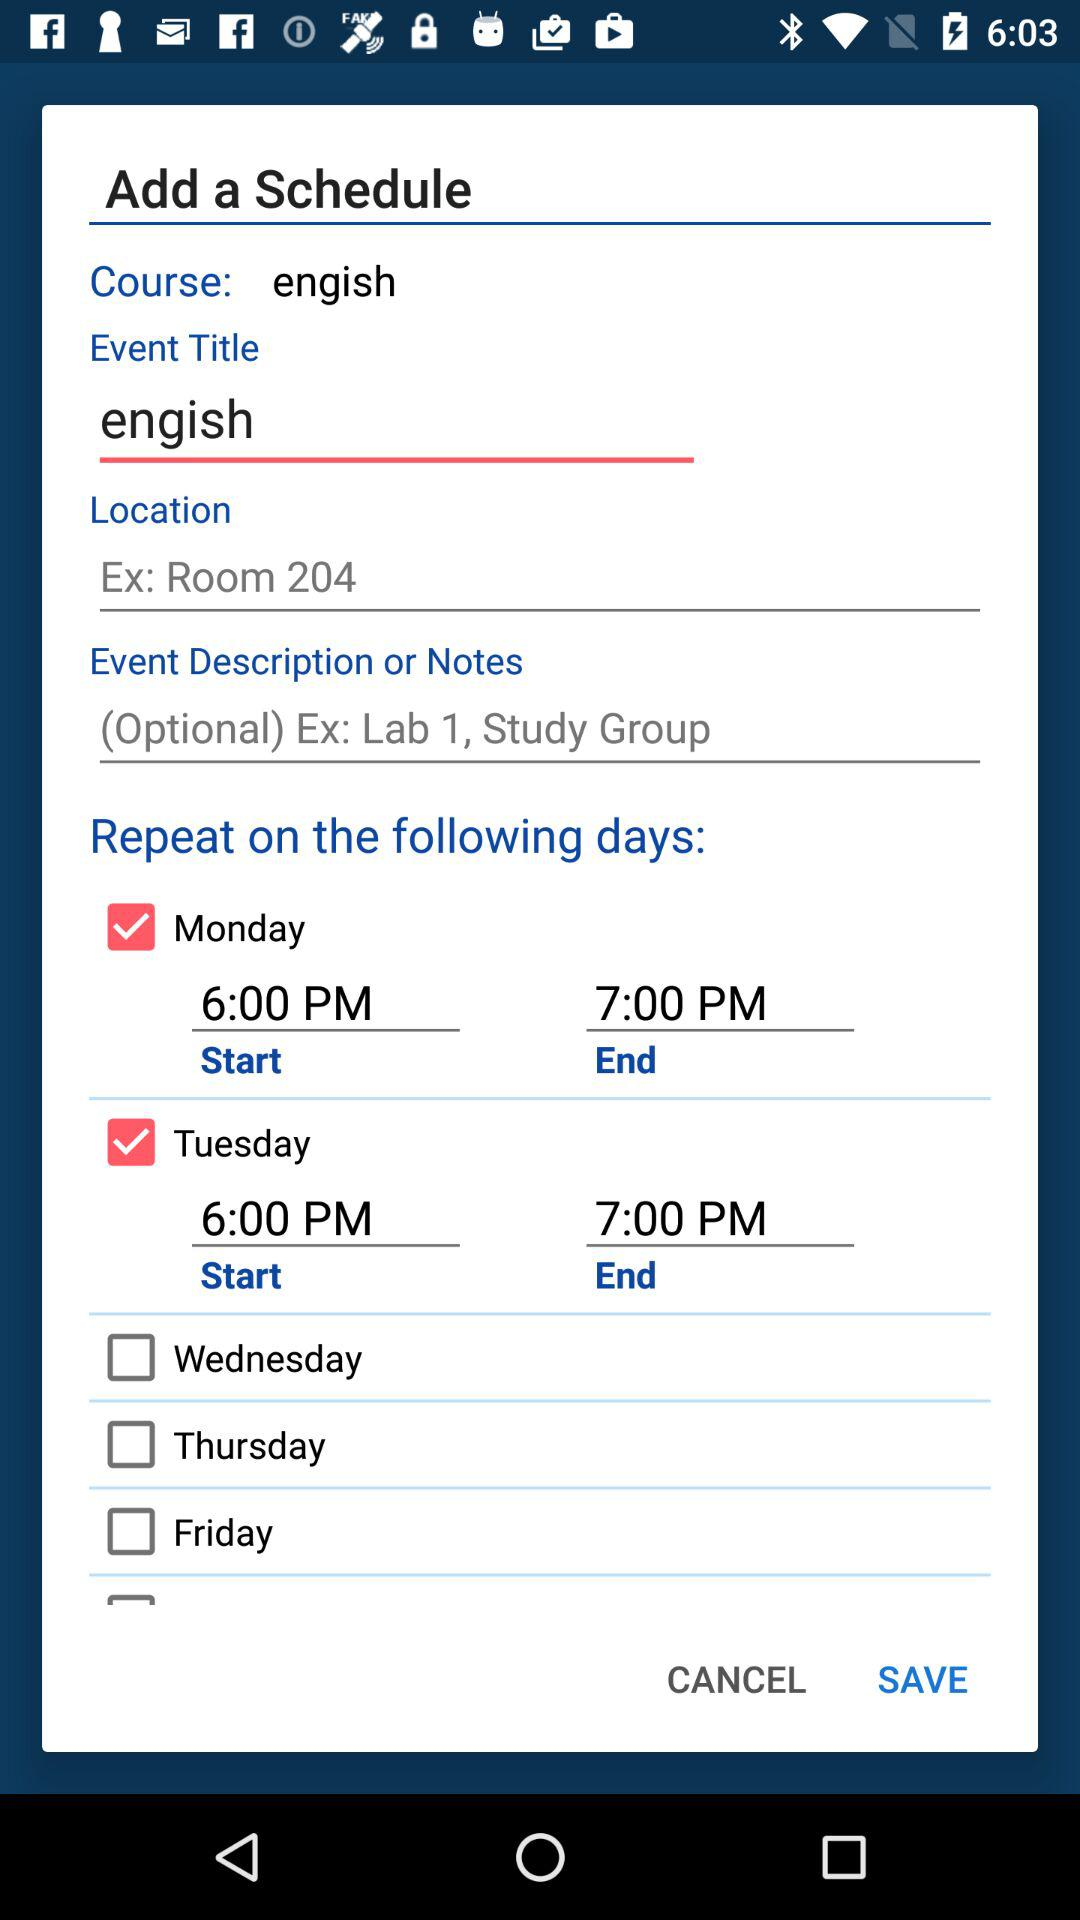What is the course name? The course name is "engish". 